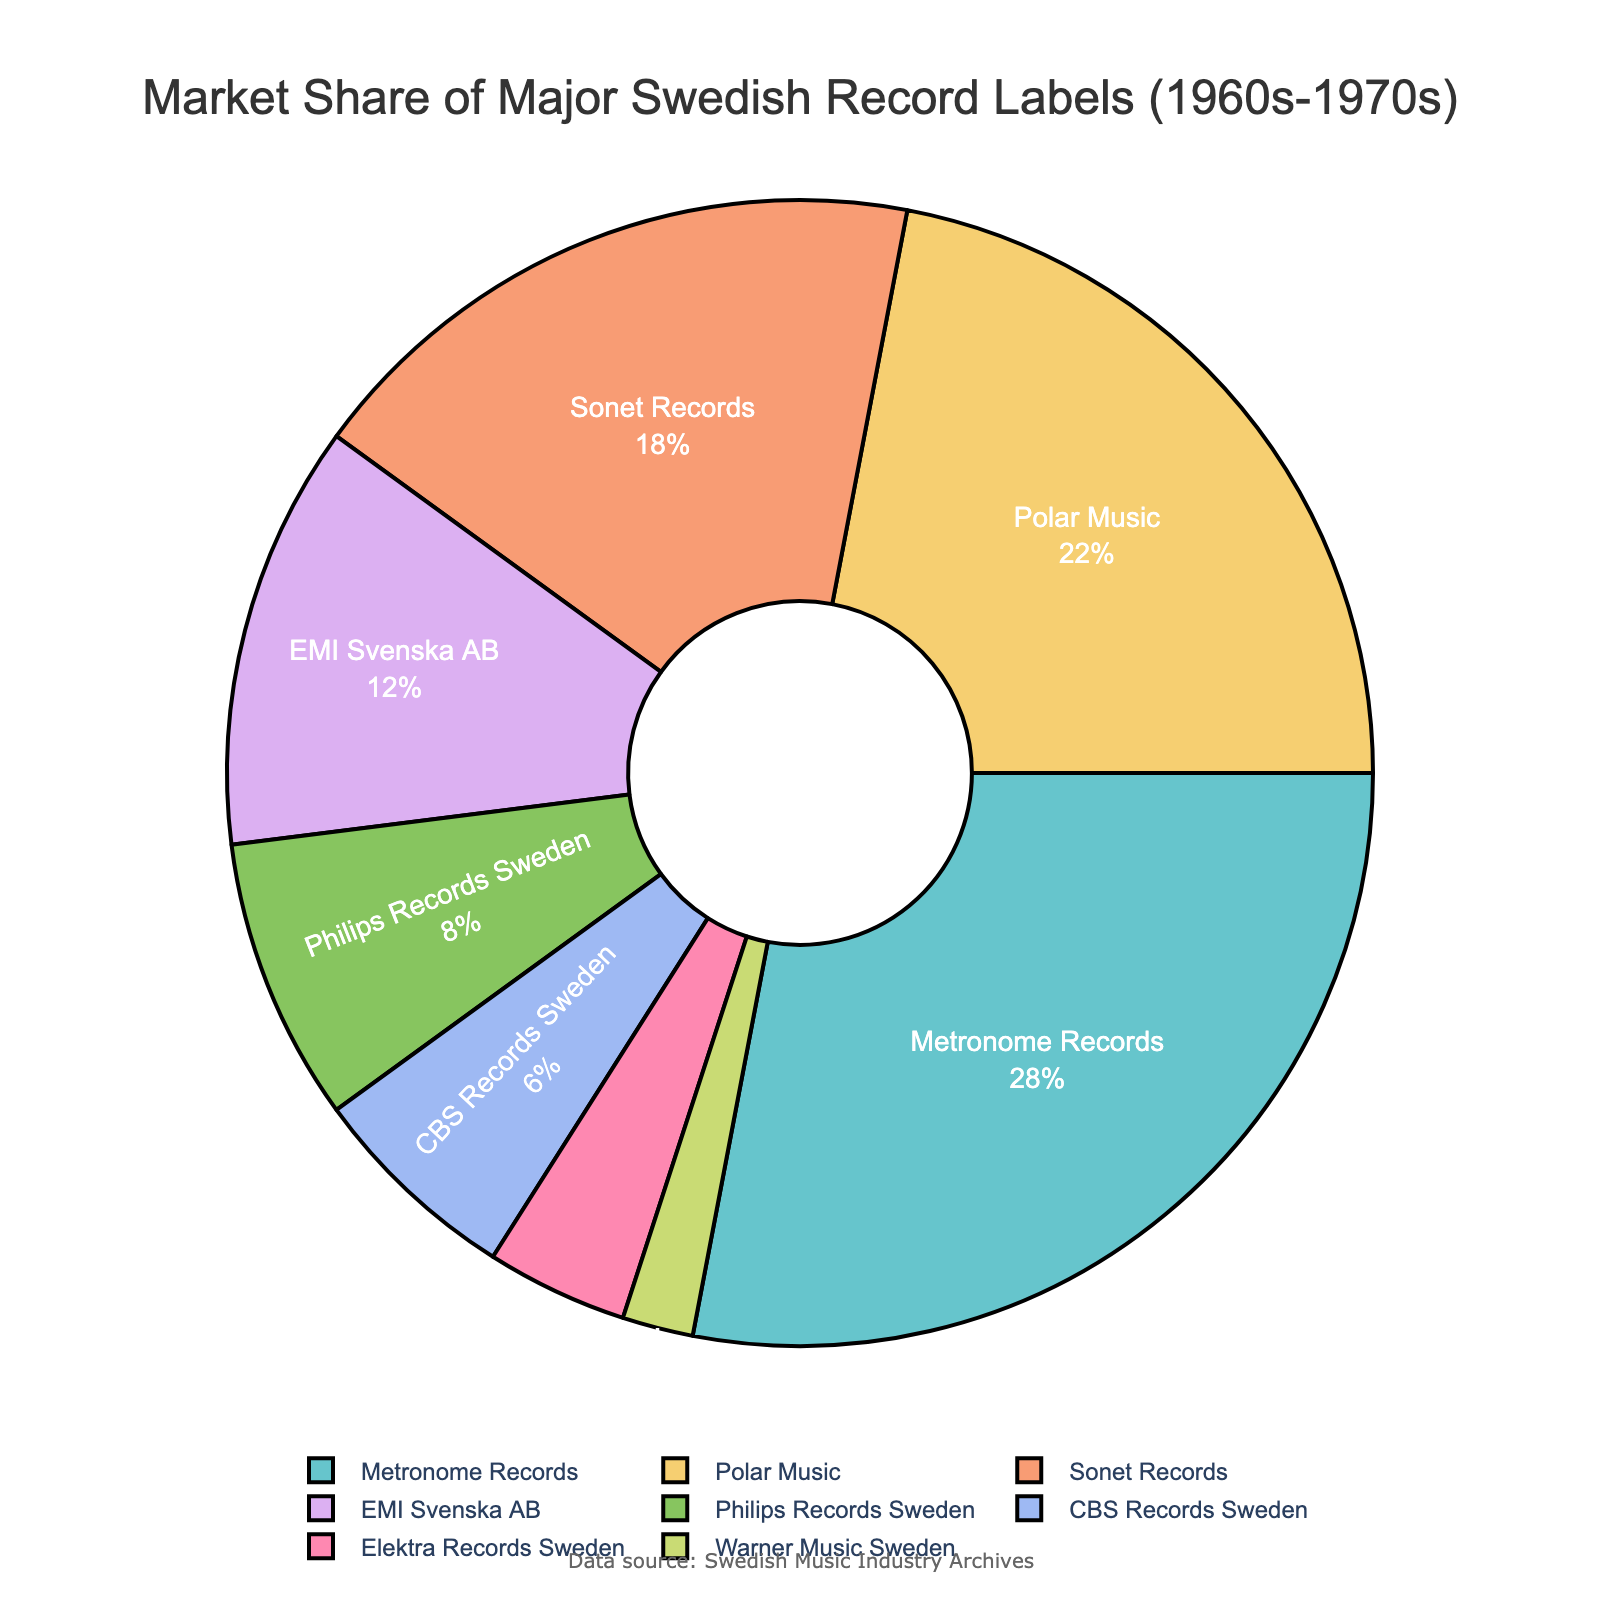Which record label has the largest market share? The figure shows different segments of the pie chart representing various record labels. The largest segment represents the record label with the highest market share.
Answer: Metronome Records What is the combined market share of the three smallest record labels? To find the combined market share, identify the three smallest segments in the pie chart (Elektra Records Sweden, Warner Music Sweden, and CBS Records Sweden) and add their market shares together. Elektra Records Sweden has 4%, Warner Music Sweden has 2%, and CBS Records Sweden has 6%. Their combined market share is 4% + 2% + 6% = 12%.
Answer: 12% Which two record labels have a combined market share equal to that of Metronome Records? First, note the market share of Metronome Records, which is 28%. Find two other labels whose combined market share equals this value. Polar Music has 22% and CBS Records Sweden has 6%, and their combined market share is 22% + 6% = 28%.
Answer: Polar Music and CBS Records Sweden How much more market share does Polar Music have compared to Philips Records Sweden? Identify Polar Music's market share (22%) and Philips Records Sweden's market share (8%). Calculate the difference: 22% - 8% = 14%.
Answer: 14% Among the top four record labels, which one has the second largest market share? The top four record labels by market share are Metronome Records, Polar Music, Sonet Records, and EMI Svenska AB. The second largest among these is Polar Music with 22%.
Answer: Polar Music What is the average market share of the top five record labels? Identify the market shares of the top five record labels (Metronome Records at 28%, Polar Music at 22%, Sonet Records at 18%, EMI Svenska AB at 12%, and Philips Records Sweden at 8%). Sum these values and then divide by the number of labels: (28% + 22% + 18% + 12% + 8%) / 5 = 88% / 5 = 17.6%.
Answer: 17.6% If Metronome Records lost 5% of its market share and Polar Music gained 5% more, how would their positions in the chart change? Subtract 5% from Metronome Records' share and add it to Polar Music's share: Metronome Records' new share would be 28% - 5% = 23%, and Polar Music's new share would be 22% + 5% = 27%. Polar Music would then have the largest market share, and Metronome Records would have the second largest.
Answer: Polar Music would be the largest, Metronome Records would be the second largest Which record label's segment is represented by a light pastel color and larger than that of EMI Svenska AB? Polar Music has a pastel segment color and is larger than EMI Svenska AB, which has a 12% market share. Polar Music has a 22% market share, making it larger and one of the pastel-colored segments.
Answer: Polar Music 